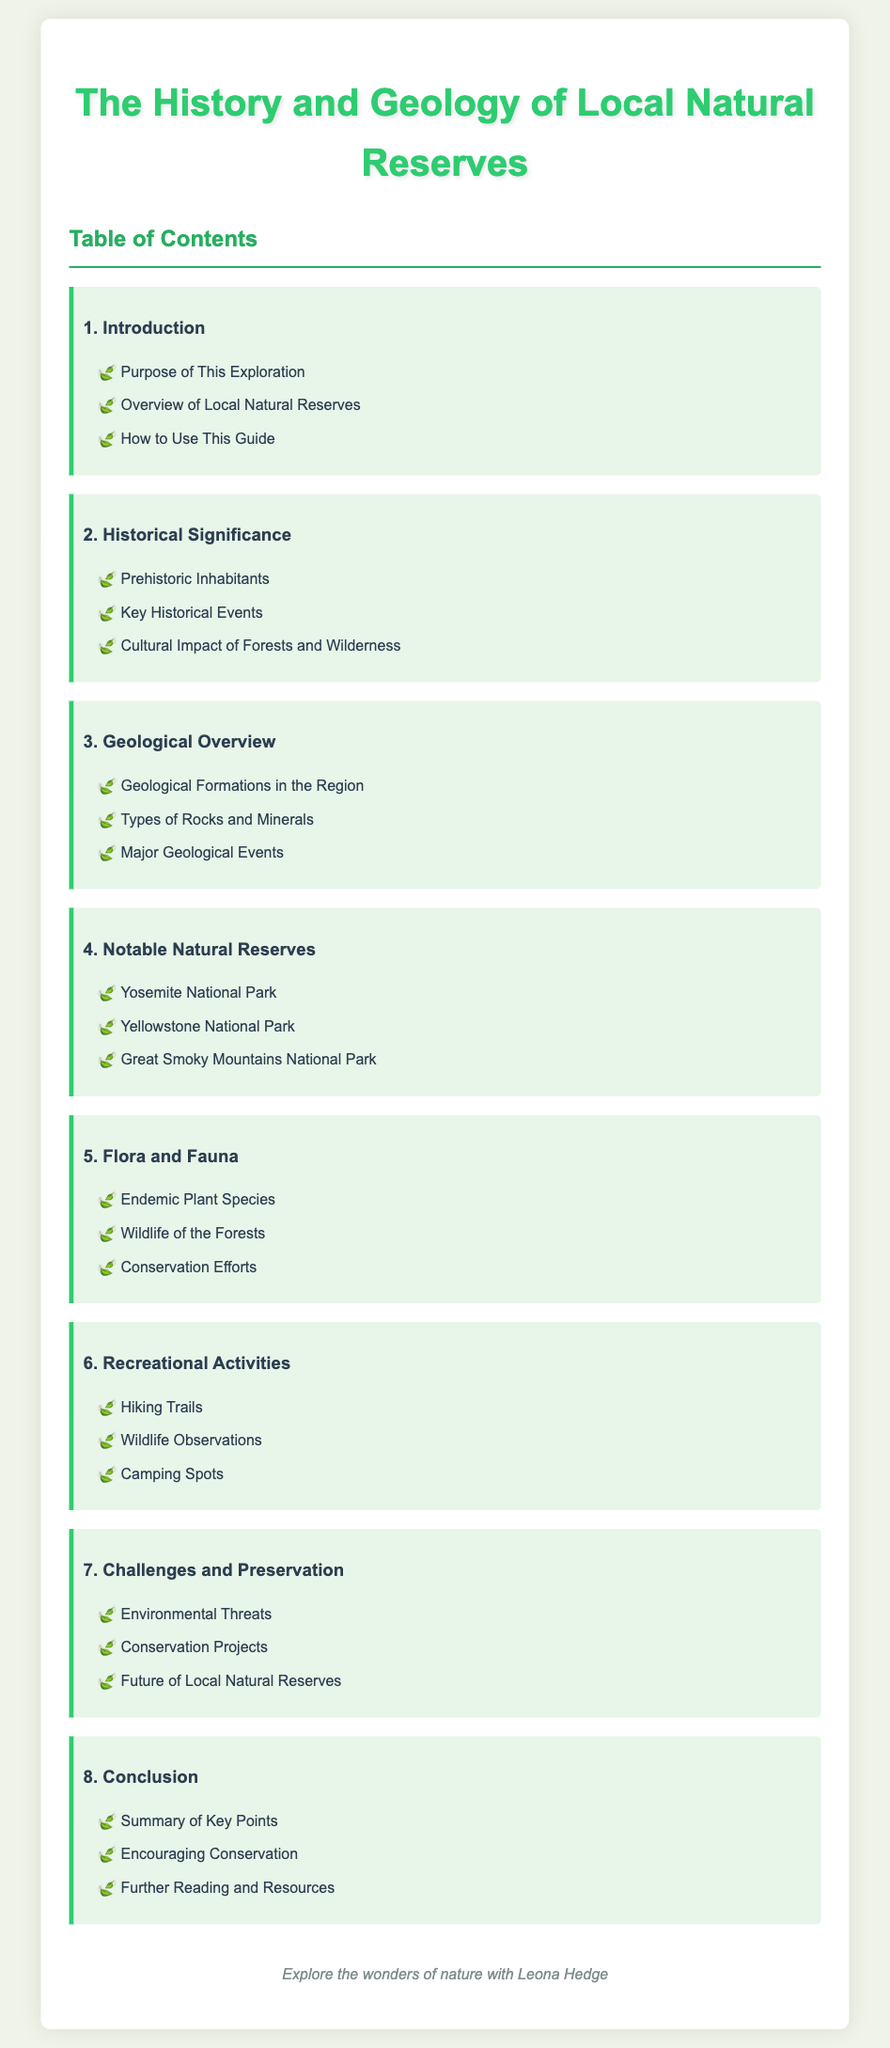What is the title of the document? The title of the document is prominently displayed at the top of the content.
Answer: The History and Geology of Local Natural Reserves How many main chapters are in the document? The number of main chapters can be counted from the Table of Contents section.
Answer: 8 What section discusses prehistoric inhabitants? The section that discusses prehistoric inhabitants is found under the historical significance chapter.
Answer: Prehistoric Inhabitants Which natural reserve is mentioned first in the notable natural reserves chapter? The first natural reserve listed is the first item in the notable natural reserves chapter.
Answer: Yosemite National Park What is the focus of chapter 7? The title of chapter 7 provides insight into its main theme, which deals with environmental challenges.
Answer: Challenges and Preservation Which topic addresses conservation efforts? The topic related to conservation can be found under the flora and fauna chapter.
Answer: Conservation Efforts What is the last section of the document? The last section title can be found under the conclusion chapter.
Answer: Further Reading and Resources How many sections are in the geological overview chapter? The sections can be counted within the geological overview chapter.
Answer: 3 